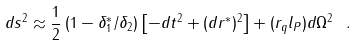<formula> <loc_0><loc_0><loc_500><loc_500>d s ^ { 2 } \approx \frac { 1 } { 2 } \left ( 1 - { \delta _ { 1 } ^ { * } } / { \delta _ { 2 } } \right ) \left [ - d t ^ { 2 } + ( d r ^ { * } ) ^ { 2 } \right ] + ( r _ { q } l _ { P } ) d \Omega ^ { 2 } \ .</formula> 